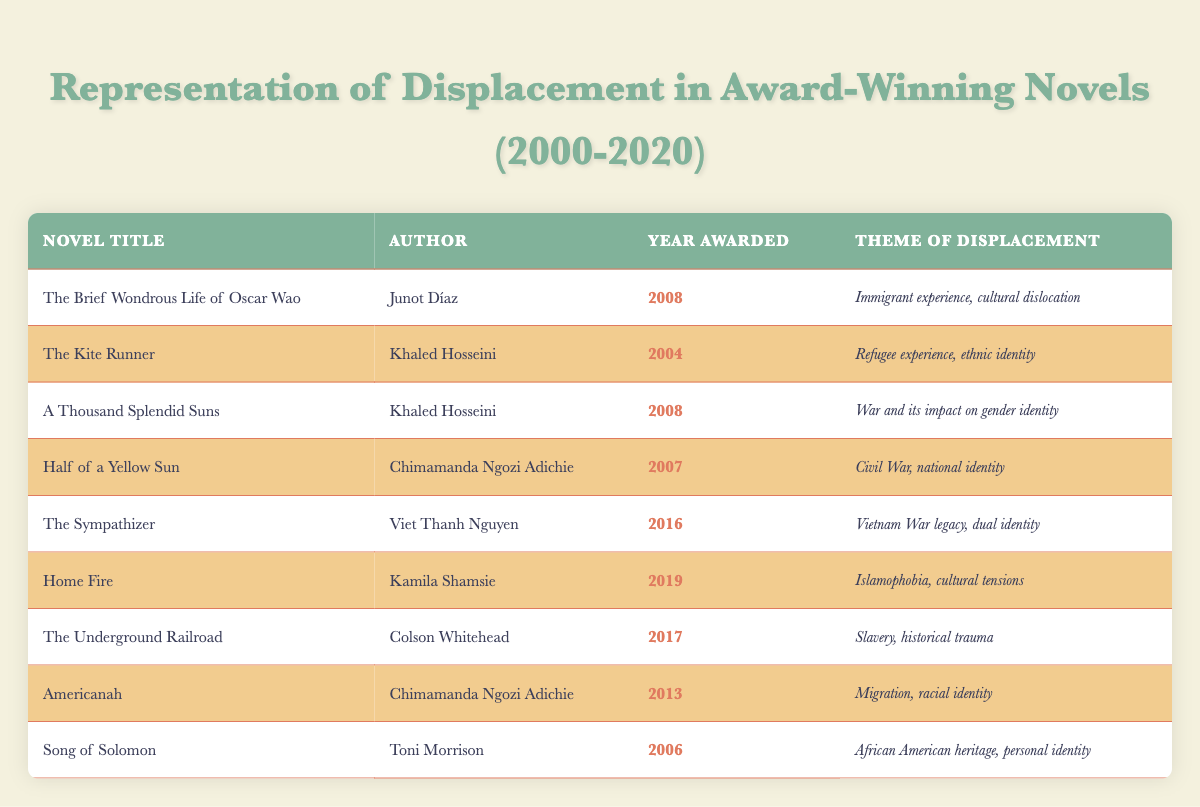What are the titles of the novels awarded in 2008? The table presents three entries for the year 2008: "The Brief Wondrous Life of Oscar Wao" by Junot Díaz and "A Thousand Splendid Suns" by Khaled Hosseini. Both these titles were awarded in 2008.
Answer: "The Brief Wondrous Life of Oscar Wao; A Thousand Splendid Suns" How many novels address themes related to war? Upon examining the table for themes that explicitly mention "war," there are three novels: "A Thousand Splendid Suns" (2008), "Half of a Yellow Sun" (2007), and "The Sympathizer" (2016). Counting these, we have a total of three.
Answer: 3 Which author has won awards for more than one novel in this list? By reviewing the authorship of the novels, both Khaled Hosseini and Chimamanda Ngozi Adichie appear multiple times: Hosseini with "The Kite Runner" (2004) and "A Thousand Splendid Suns" (2008), and Adichie with "Half of a Yellow Sun" (2007) and "Americanah" (2013). Therefore, both authors won awards for more than one novel.
Answer: Khaled Hosseini; Chimamanda Ngozi Adichie Is "The God of Small Things" included in the table? The title "The God of Small Things" is listed in the table, but it indicates a year awarded in 1997, which is outside the specified range of 2000 to 2020. Therefore, it is not included in the context of this table.
Answer: No Which theme appears most frequently among the novels listed? By examining the themes of displacement across the novels, we find unique categories, with particular emphasis on "cultural identity." Both "Americanah" and "Home Fire" (2019) touch on similar themes, but most themes are distinct. Each theme only represents one novel, indicating no repeated themes across the dataset.
Answer: None, all themes are unique 